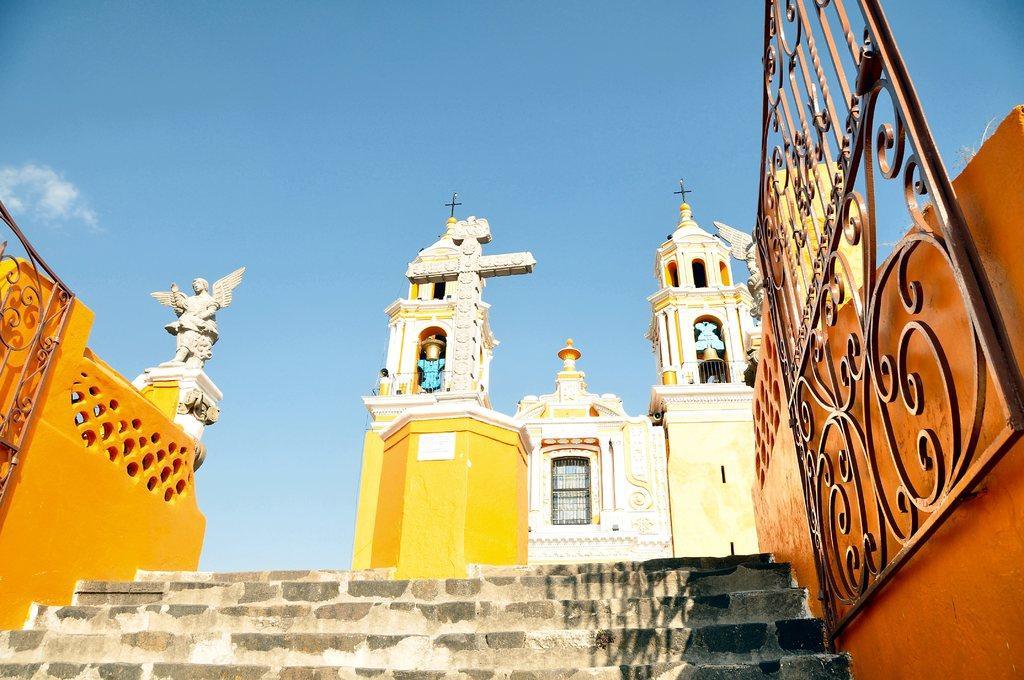How would you summarize this image in a sentence or two? In this image there is the sky towards the top of the image, there are clouds in the sky, there is a church, there is a sculptor, there is a wall towards the right of the image, there is a wall towards the left of the image, there are bells, there is gate towards the right of the image, there is gate towards the left of the image, there are stairs towards the bottom of the image, there is a window. 